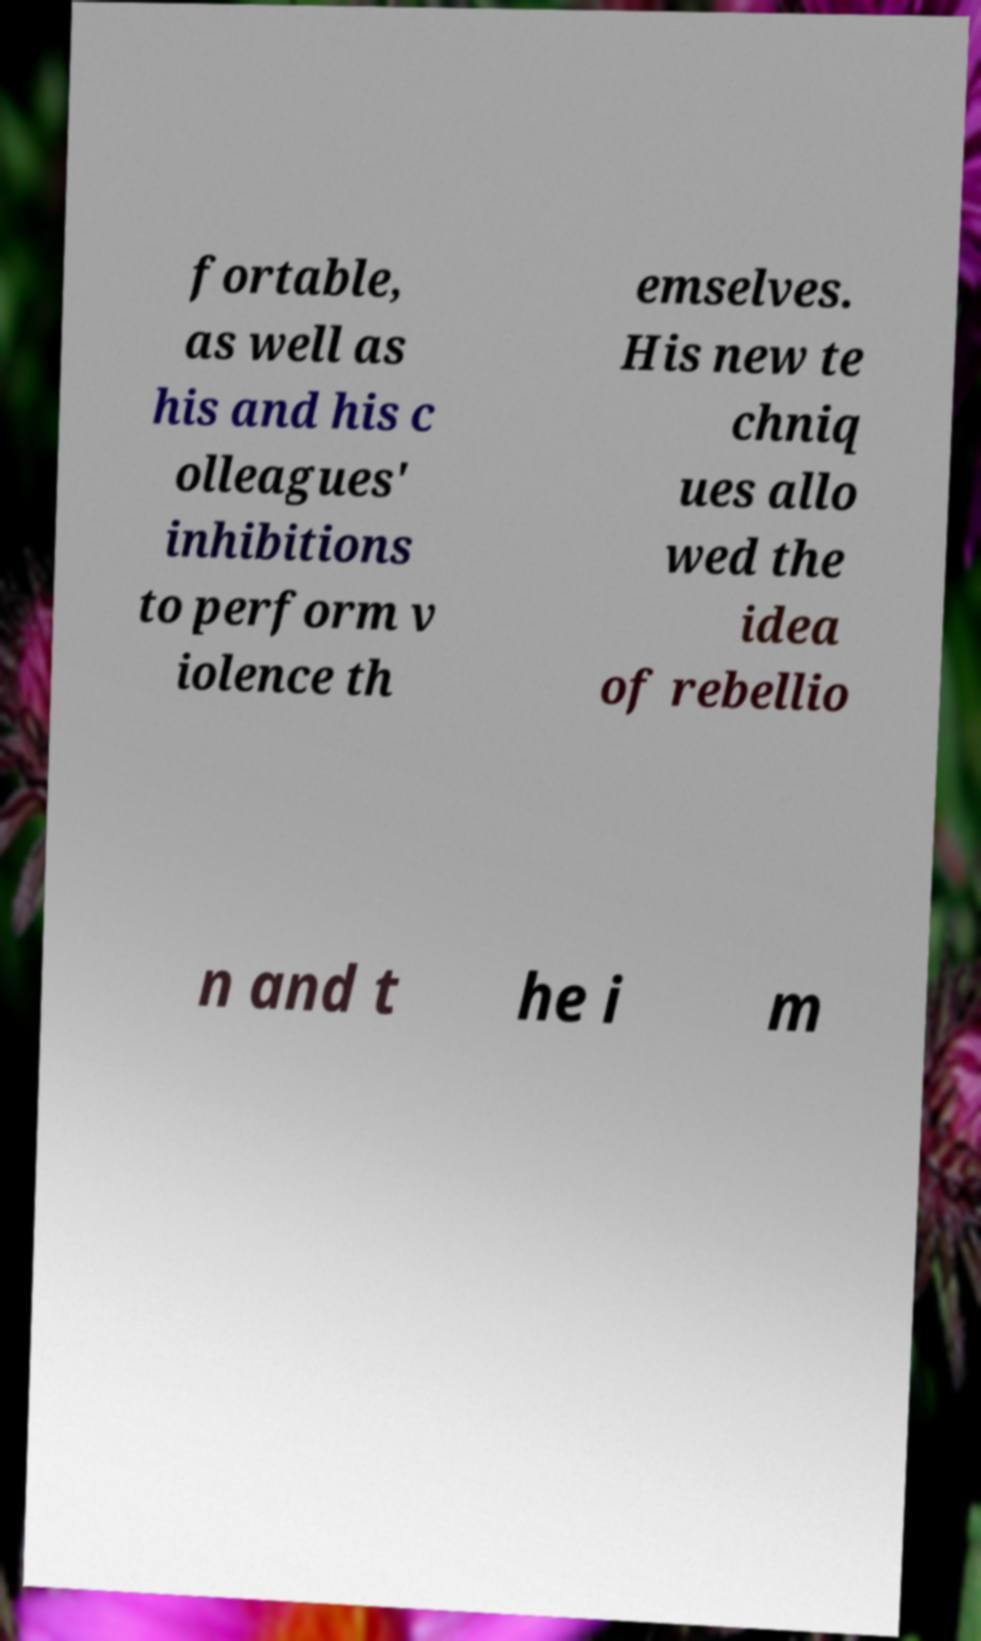Can you accurately transcribe the text from the provided image for me? fortable, as well as his and his c olleagues' inhibitions to perform v iolence th emselves. His new te chniq ues allo wed the idea of rebellio n and t he i m 